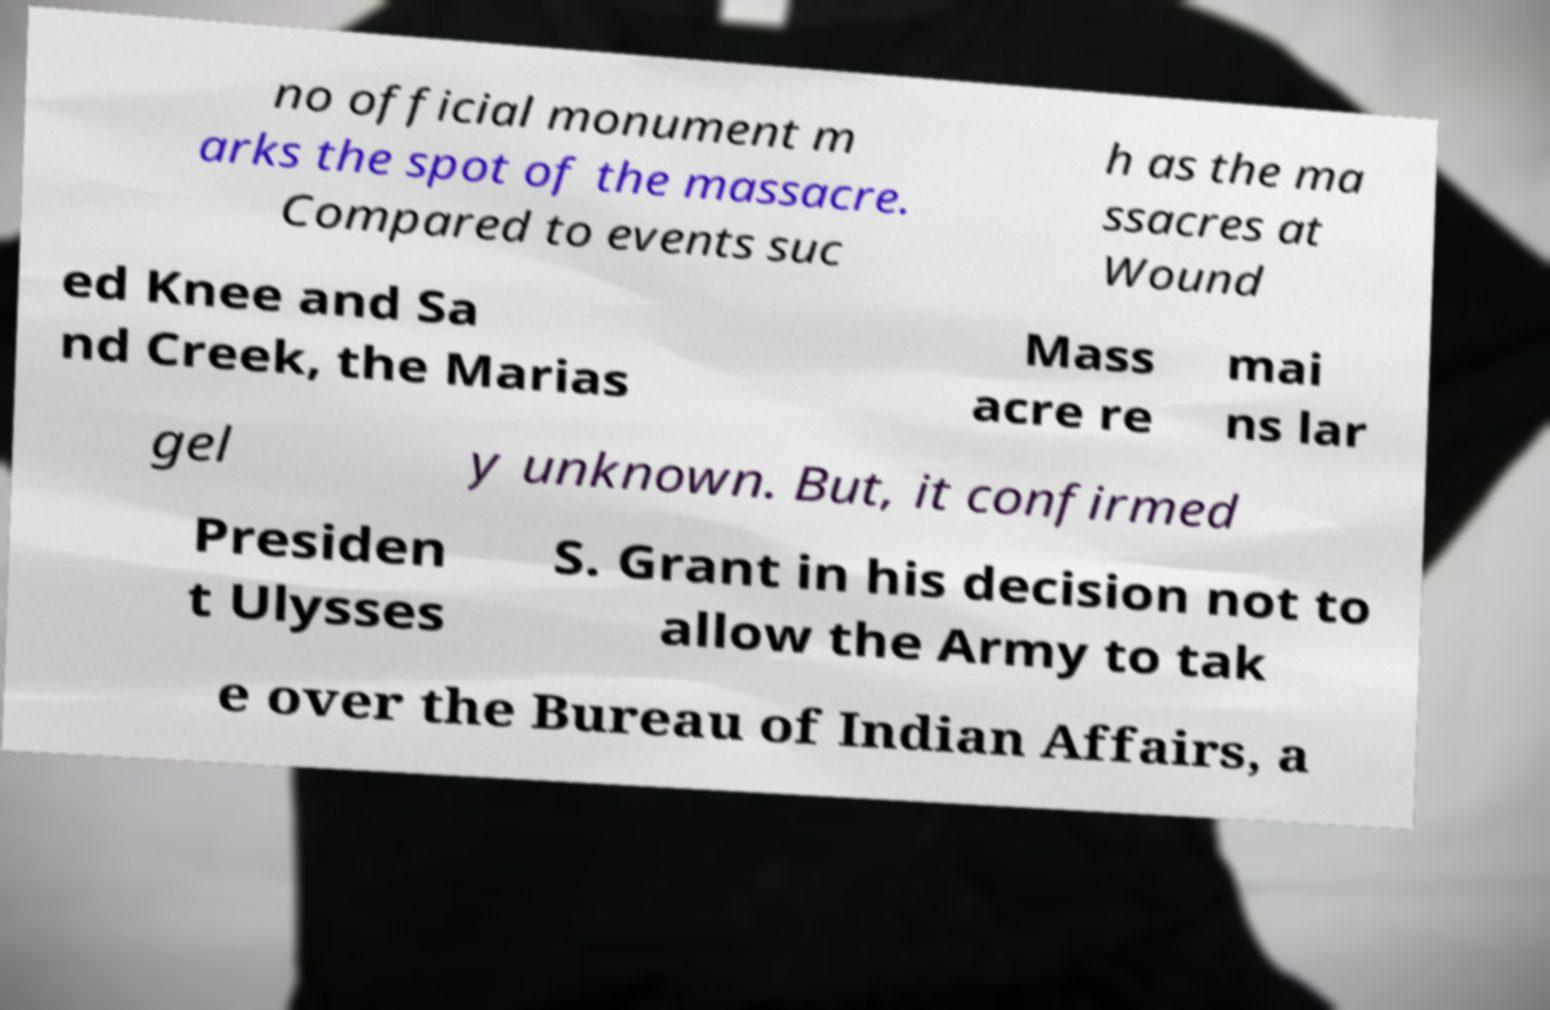I need the written content from this picture converted into text. Can you do that? no official monument m arks the spot of the massacre. Compared to events suc h as the ma ssacres at Wound ed Knee and Sa nd Creek, the Marias Mass acre re mai ns lar gel y unknown. But, it confirmed Presiden t Ulysses S. Grant in his decision not to allow the Army to tak e over the Bureau of Indian Affairs, a 